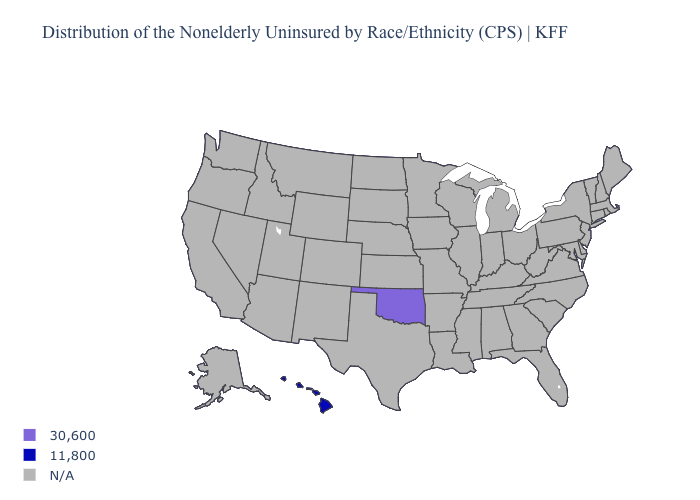Name the states that have a value in the range 30,600?
Short answer required. Oklahoma. Does the map have missing data?
Answer briefly. Yes. Name the states that have a value in the range 30,600?
Give a very brief answer. Oklahoma. Name the states that have a value in the range 30,600?
Short answer required. Oklahoma. Name the states that have a value in the range 11,800?
Concise answer only. Hawaii. Name the states that have a value in the range 30,600?
Write a very short answer. Oklahoma. Name the states that have a value in the range 30,600?
Be succinct. Oklahoma. Name the states that have a value in the range N/A?
Quick response, please. Alabama, Alaska, Arizona, Arkansas, California, Colorado, Connecticut, Delaware, Florida, Georgia, Idaho, Illinois, Indiana, Iowa, Kansas, Kentucky, Louisiana, Maine, Maryland, Massachusetts, Michigan, Minnesota, Mississippi, Missouri, Montana, Nebraska, Nevada, New Hampshire, New Jersey, New Mexico, New York, North Carolina, North Dakota, Ohio, Oregon, Pennsylvania, Rhode Island, South Carolina, South Dakota, Tennessee, Texas, Utah, Vermont, Virginia, Washington, West Virginia, Wisconsin, Wyoming. Name the states that have a value in the range 30,600?
Short answer required. Oklahoma. Does Hawaii have the lowest value in the USA?
Short answer required. Yes. 